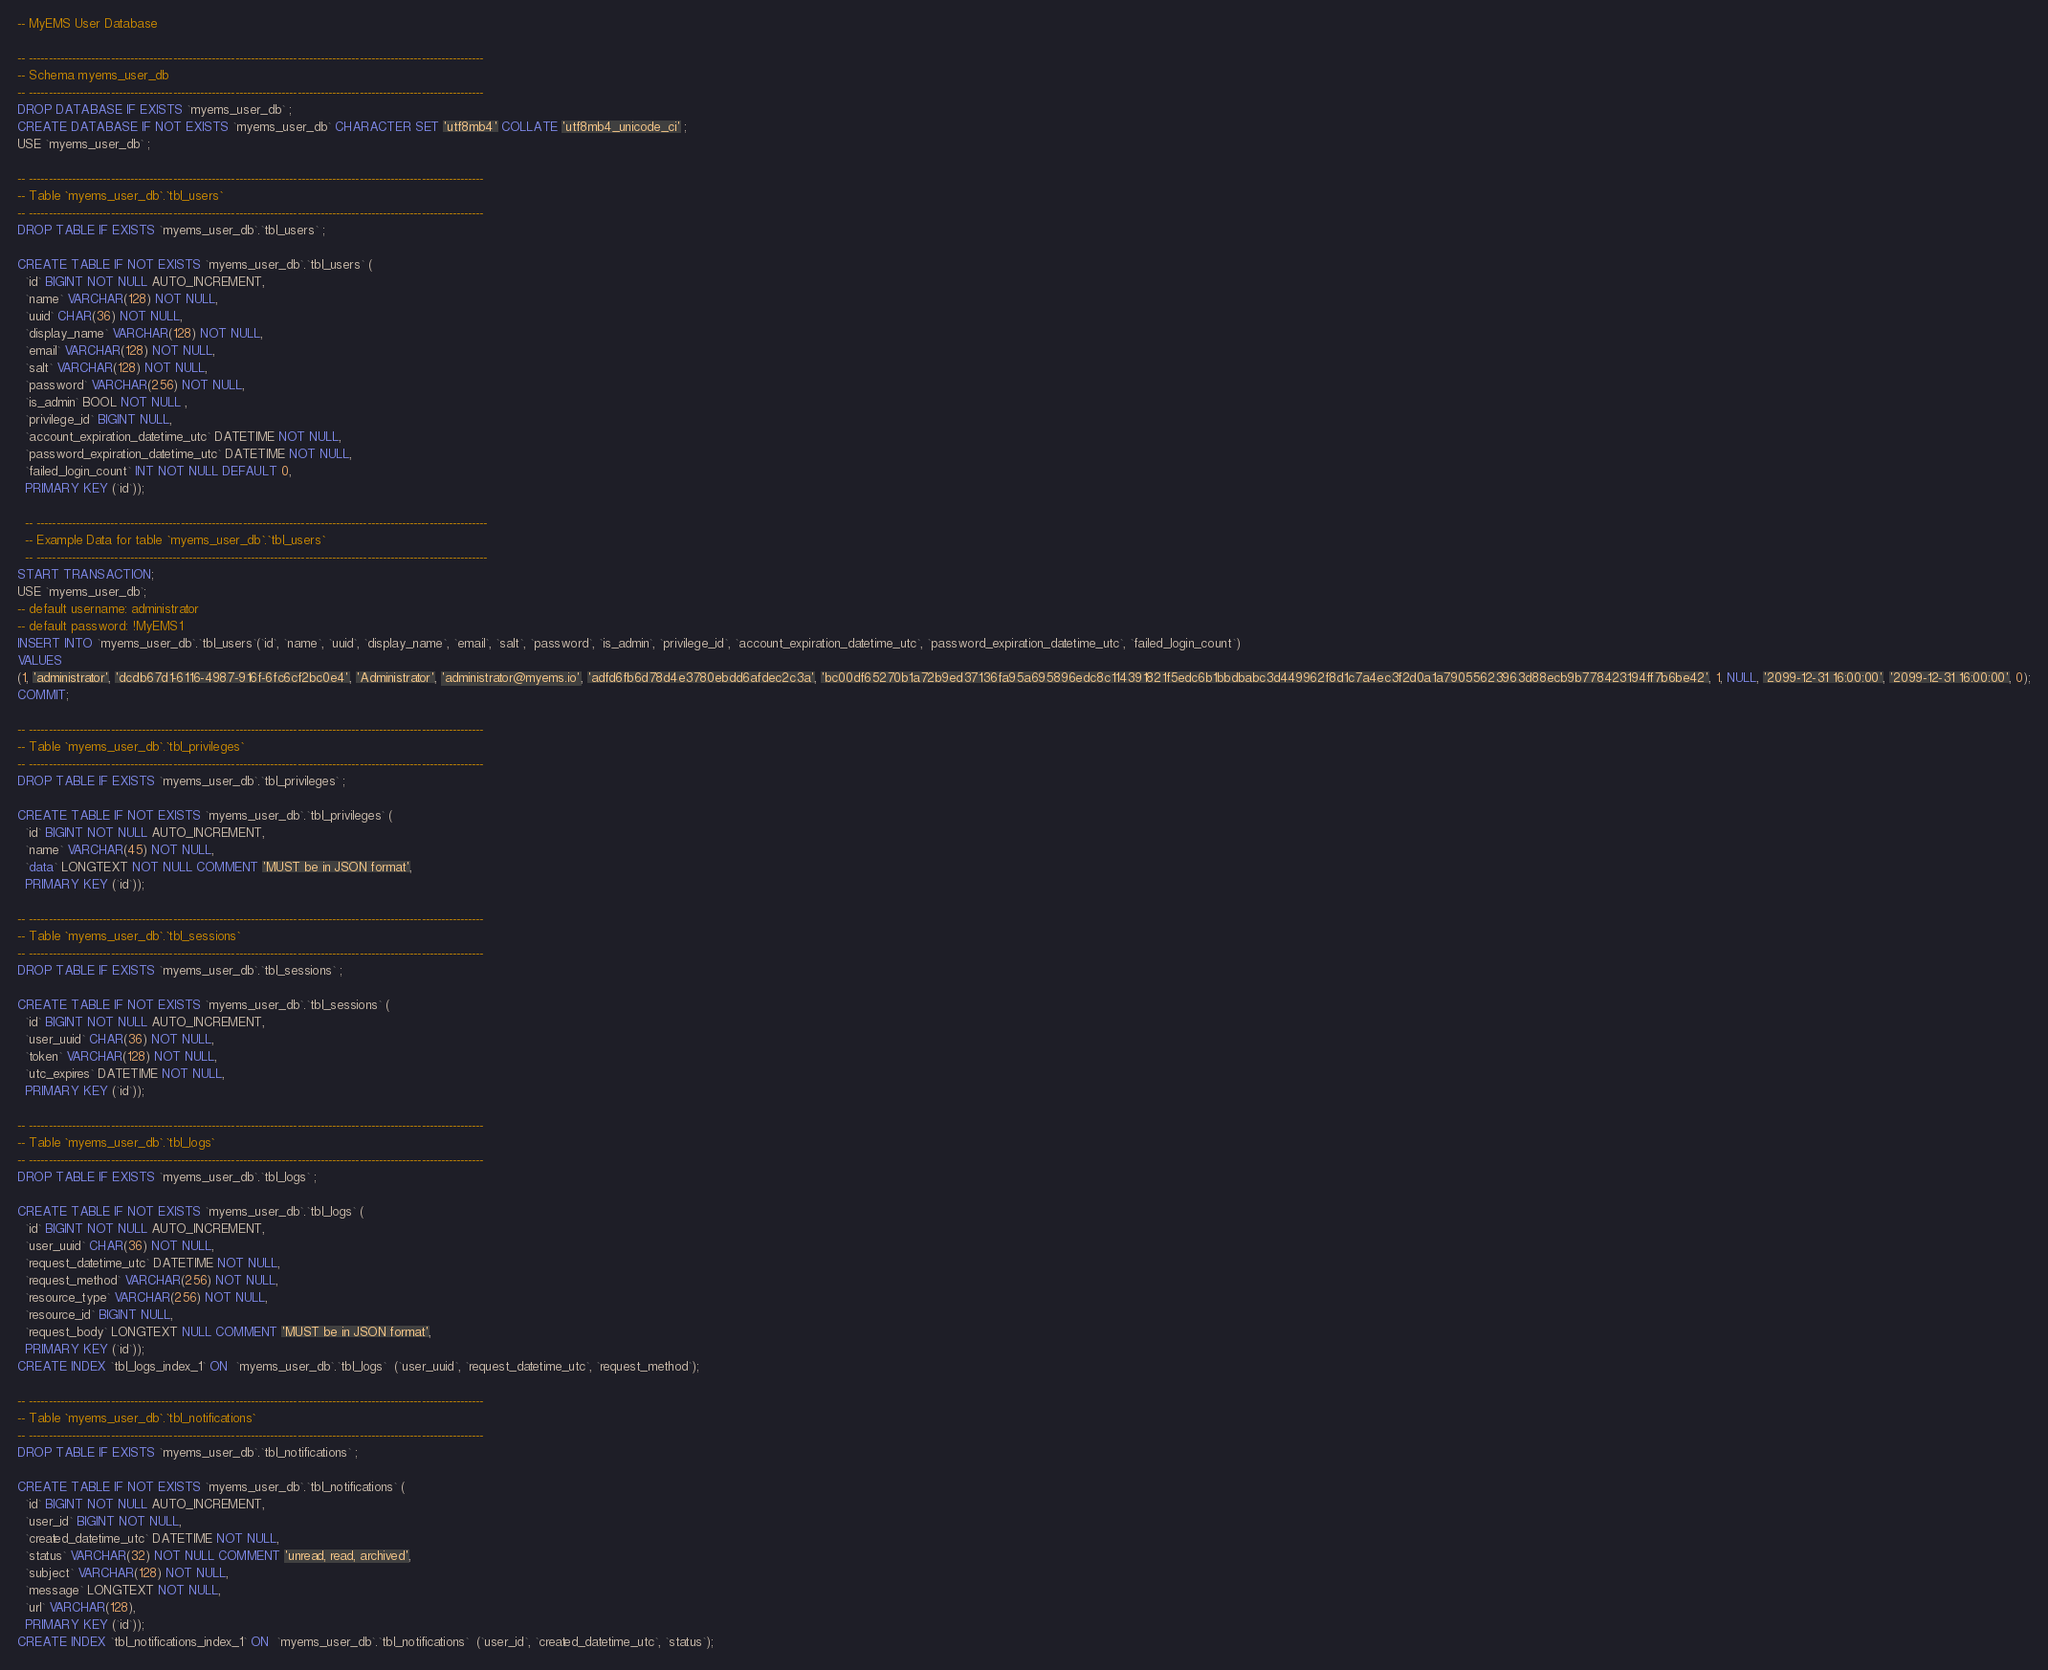Convert code to text. <code><loc_0><loc_0><loc_500><loc_500><_SQL_>-- MyEMS User Database

-- ---------------------------------------------------------------------------------------------------------------------
-- Schema myems_user_db
-- ---------------------------------------------------------------------------------------------------------------------
DROP DATABASE IF EXISTS `myems_user_db` ;
CREATE DATABASE IF NOT EXISTS `myems_user_db` CHARACTER SET 'utf8mb4' COLLATE 'utf8mb4_unicode_ci' ;
USE `myems_user_db` ;

-- ---------------------------------------------------------------------------------------------------------------------
-- Table `myems_user_db`.`tbl_users`
-- ---------------------------------------------------------------------------------------------------------------------
DROP TABLE IF EXISTS `myems_user_db`.`tbl_users` ;

CREATE TABLE IF NOT EXISTS `myems_user_db`.`tbl_users` (
  `id` BIGINT NOT NULL AUTO_INCREMENT,
  `name` VARCHAR(128) NOT NULL,
  `uuid` CHAR(36) NOT NULL,
  `display_name` VARCHAR(128) NOT NULL,
  `email` VARCHAR(128) NOT NULL,
  `salt` VARCHAR(128) NOT NULL,
  `password` VARCHAR(256) NOT NULL,
  `is_admin` BOOL NOT NULL ,
  `privilege_id` BIGINT NULL,
  `account_expiration_datetime_utc` DATETIME NOT NULL,
  `password_expiration_datetime_utc` DATETIME NOT NULL,
  `failed_login_count` INT NOT NULL DEFAULT 0,
  PRIMARY KEY (`id`));

  -- --------------------------------------------------------------------------------------------------------------------
  -- Example Data for table `myems_user_db`.`tbl_users`
  -- --------------------------------------------------------------------------------------------------------------------
START TRANSACTION;
USE `myems_user_db`;
-- default username: administrator
-- default password: !MyEMS1
INSERT INTO `myems_user_db`.`tbl_users`(`id`, `name`, `uuid`, `display_name`, `email`, `salt`, `password`, `is_admin`, `privilege_id`, `account_expiration_datetime_utc`, `password_expiration_datetime_utc`, `failed_login_count`)
VALUES
(1, 'administrator', 'dcdb67d1-6116-4987-916f-6fc6cf2bc0e4', 'Administrator', 'administrator@myems.io', 'adfd6fb6d78d4e3780ebdd6afdec2c3a', 'bc00df65270b1a72b9ed37136fa95a695896edc8c114391821f5edc6b1bbdbabc3d449962f8d1c7a4ec3f2d0a1a79055623963d88ecb9b778423194ff7b6be42', 1, NULL, '2099-12-31 16:00:00', '2099-12-31 16:00:00', 0);
COMMIT;

-- ---------------------------------------------------------------------------------------------------------------------
-- Table `myems_user_db`.`tbl_privileges`
-- ---------------------------------------------------------------------------------------------------------------------
DROP TABLE IF EXISTS `myems_user_db`.`tbl_privileges` ;

CREATE TABLE IF NOT EXISTS `myems_user_db`.`tbl_privileges` (
  `id` BIGINT NOT NULL AUTO_INCREMENT,
  `name` VARCHAR(45) NOT NULL,
  `data` LONGTEXT NOT NULL COMMENT 'MUST be in JSON format',
  PRIMARY KEY (`id`));

-- ---------------------------------------------------------------------------------------------------------------------
-- Table `myems_user_db`.`tbl_sessions`
-- ---------------------------------------------------------------------------------------------------------------------
DROP TABLE IF EXISTS `myems_user_db`.`tbl_sessions` ;

CREATE TABLE IF NOT EXISTS `myems_user_db`.`tbl_sessions` (
  `id` BIGINT NOT NULL AUTO_INCREMENT,
  `user_uuid` CHAR(36) NOT NULL,
  `token` VARCHAR(128) NOT NULL,
  `utc_expires` DATETIME NOT NULL,
  PRIMARY KEY (`id`));

-- ---------------------------------------------------------------------------------------------------------------------
-- Table `myems_user_db`.`tbl_logs`
-- ---------------------------------------------------------------------------------------------------------------------
DROP TABLE IF EXISTS `myems_user_db`.`tbl_logs` ;

CREATE TABLE IF NOT EXISTS `myems_user_db`.`tbl_logs` (
  `id` BIGINT NOT NULL AUTO_INCREMENT,
  `user_uuid` CHAR(36) NOT NULL,
  `request_datetime_utc` DATETIME NOT NULL,
  `request_method` VARCHAR(256) NOT NULL,
  `resource_type` VARCHAR(256) NOT NULL,
  `resource_id` BIGINT NULL,
  `request_body` LONGTEXT NULL COMMENT 'MUST be in JSON format',
  PRIMARY KEY (`id`));
CREATE INDEX `tbl_logs_index_1` ON  `myems_user_db`.`tbl_logs`  (`user_uuid`, `request_datetime_utc`, `request_method`);

-- ---------------------------------------------------------------------------------------------------------------------
-- Table `myems_user_db`.`tbl_notifications`
-- ---------------------------------------------------------------------------------------------------------------------
DROP TABLE IF EXISTS `myems_user_db`.`tbl_notifications` ;

CREATE TABLE IF NOT EXISTS `myems_user_db`.`tbl_notifications` (
  `id` BIGINT NOT NULL AUTO_INCREMENT,
  `user_id` BIGINT NOT NULL,
  `created_datetime_utc` DATETIME NOT NULL,
  `status` VARCHAR(32) NOT NULL COMMENT 'unread, read, archived',
  `subject` VARCHAR(128) NOT NULL,
  `message` LONGTEXT NOT NULL,
  `url` VARCHAR(128),
  PRIMARY KEY (`id`));
CREATE INDEX `tbl_notifications_index_1` ON  `myems_user_db`.`tbl_notifications`  (`user_id`, `created_datetime_utc`, `status`);
</code> 